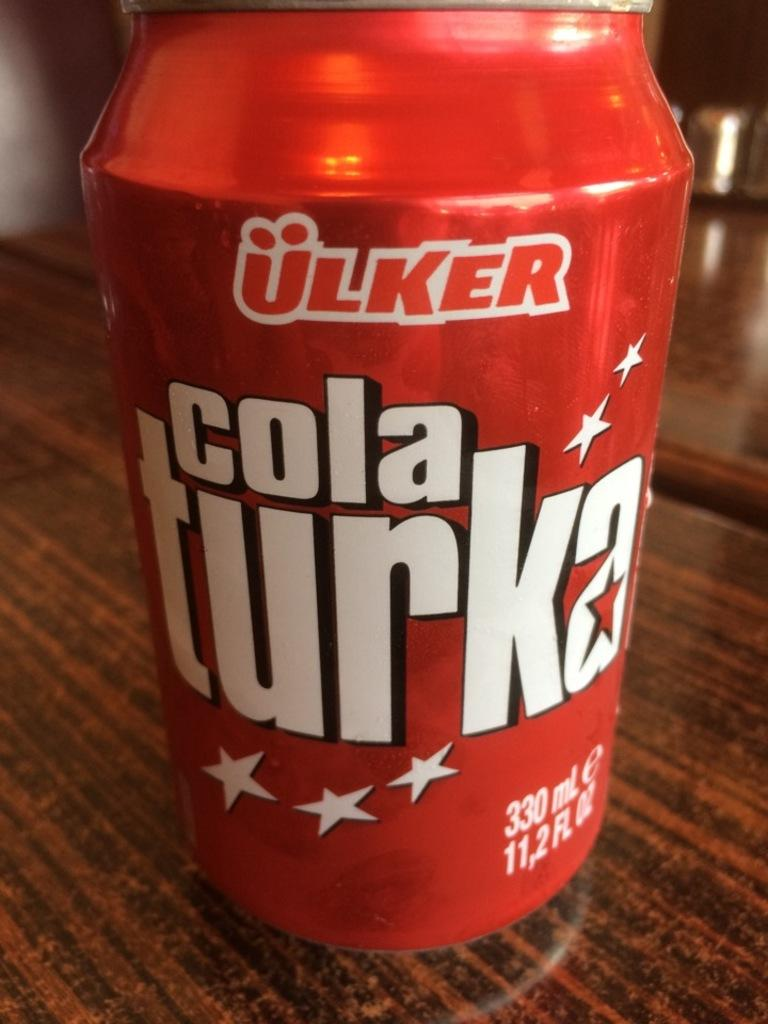<image>
Create a compact narrative representing the image presented. a close up of a Cola Turka can on a wood table 